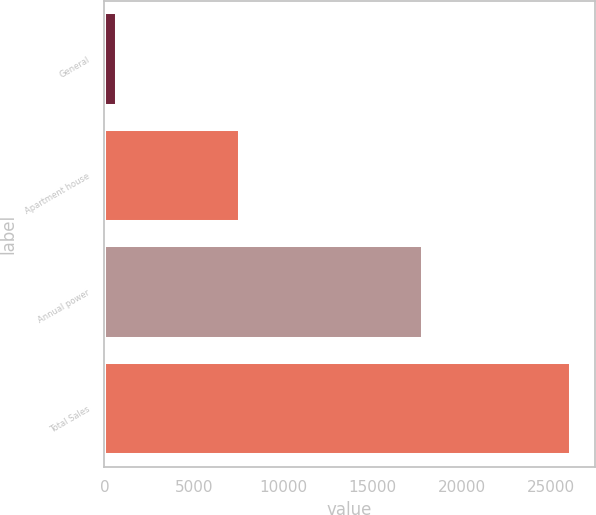Convert chart to OTSL. <chart><loc_0><loc_0><loc_500><loc_500><bar_chart><fcel>General<fcel>Apartment house<fcel>Annual power<fcel>Total Sales<nl><fcel>685<fcel>7602<fcel>17842<fcel>26129<nl></chart> 